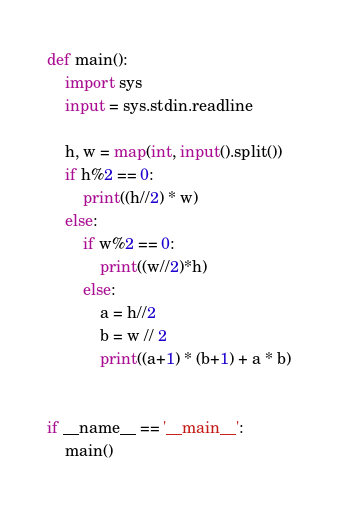Convert code to text. <code><loc_0><loc_0><loc_500><loc_500><_Python_>def main():
    import sys
    input = sys.stdin.readline

    h, w = map(int, input().split())
    if h%2 == 0:
        print((h//2) * w)
    else:
        if w%2 == 0:
            print((w//2)*h)
        else:
            a = h//2
            b = w // 2
            print((a+1) * (b+1) + a * b)


if __name__ == '__main__':
    main()
</code> 